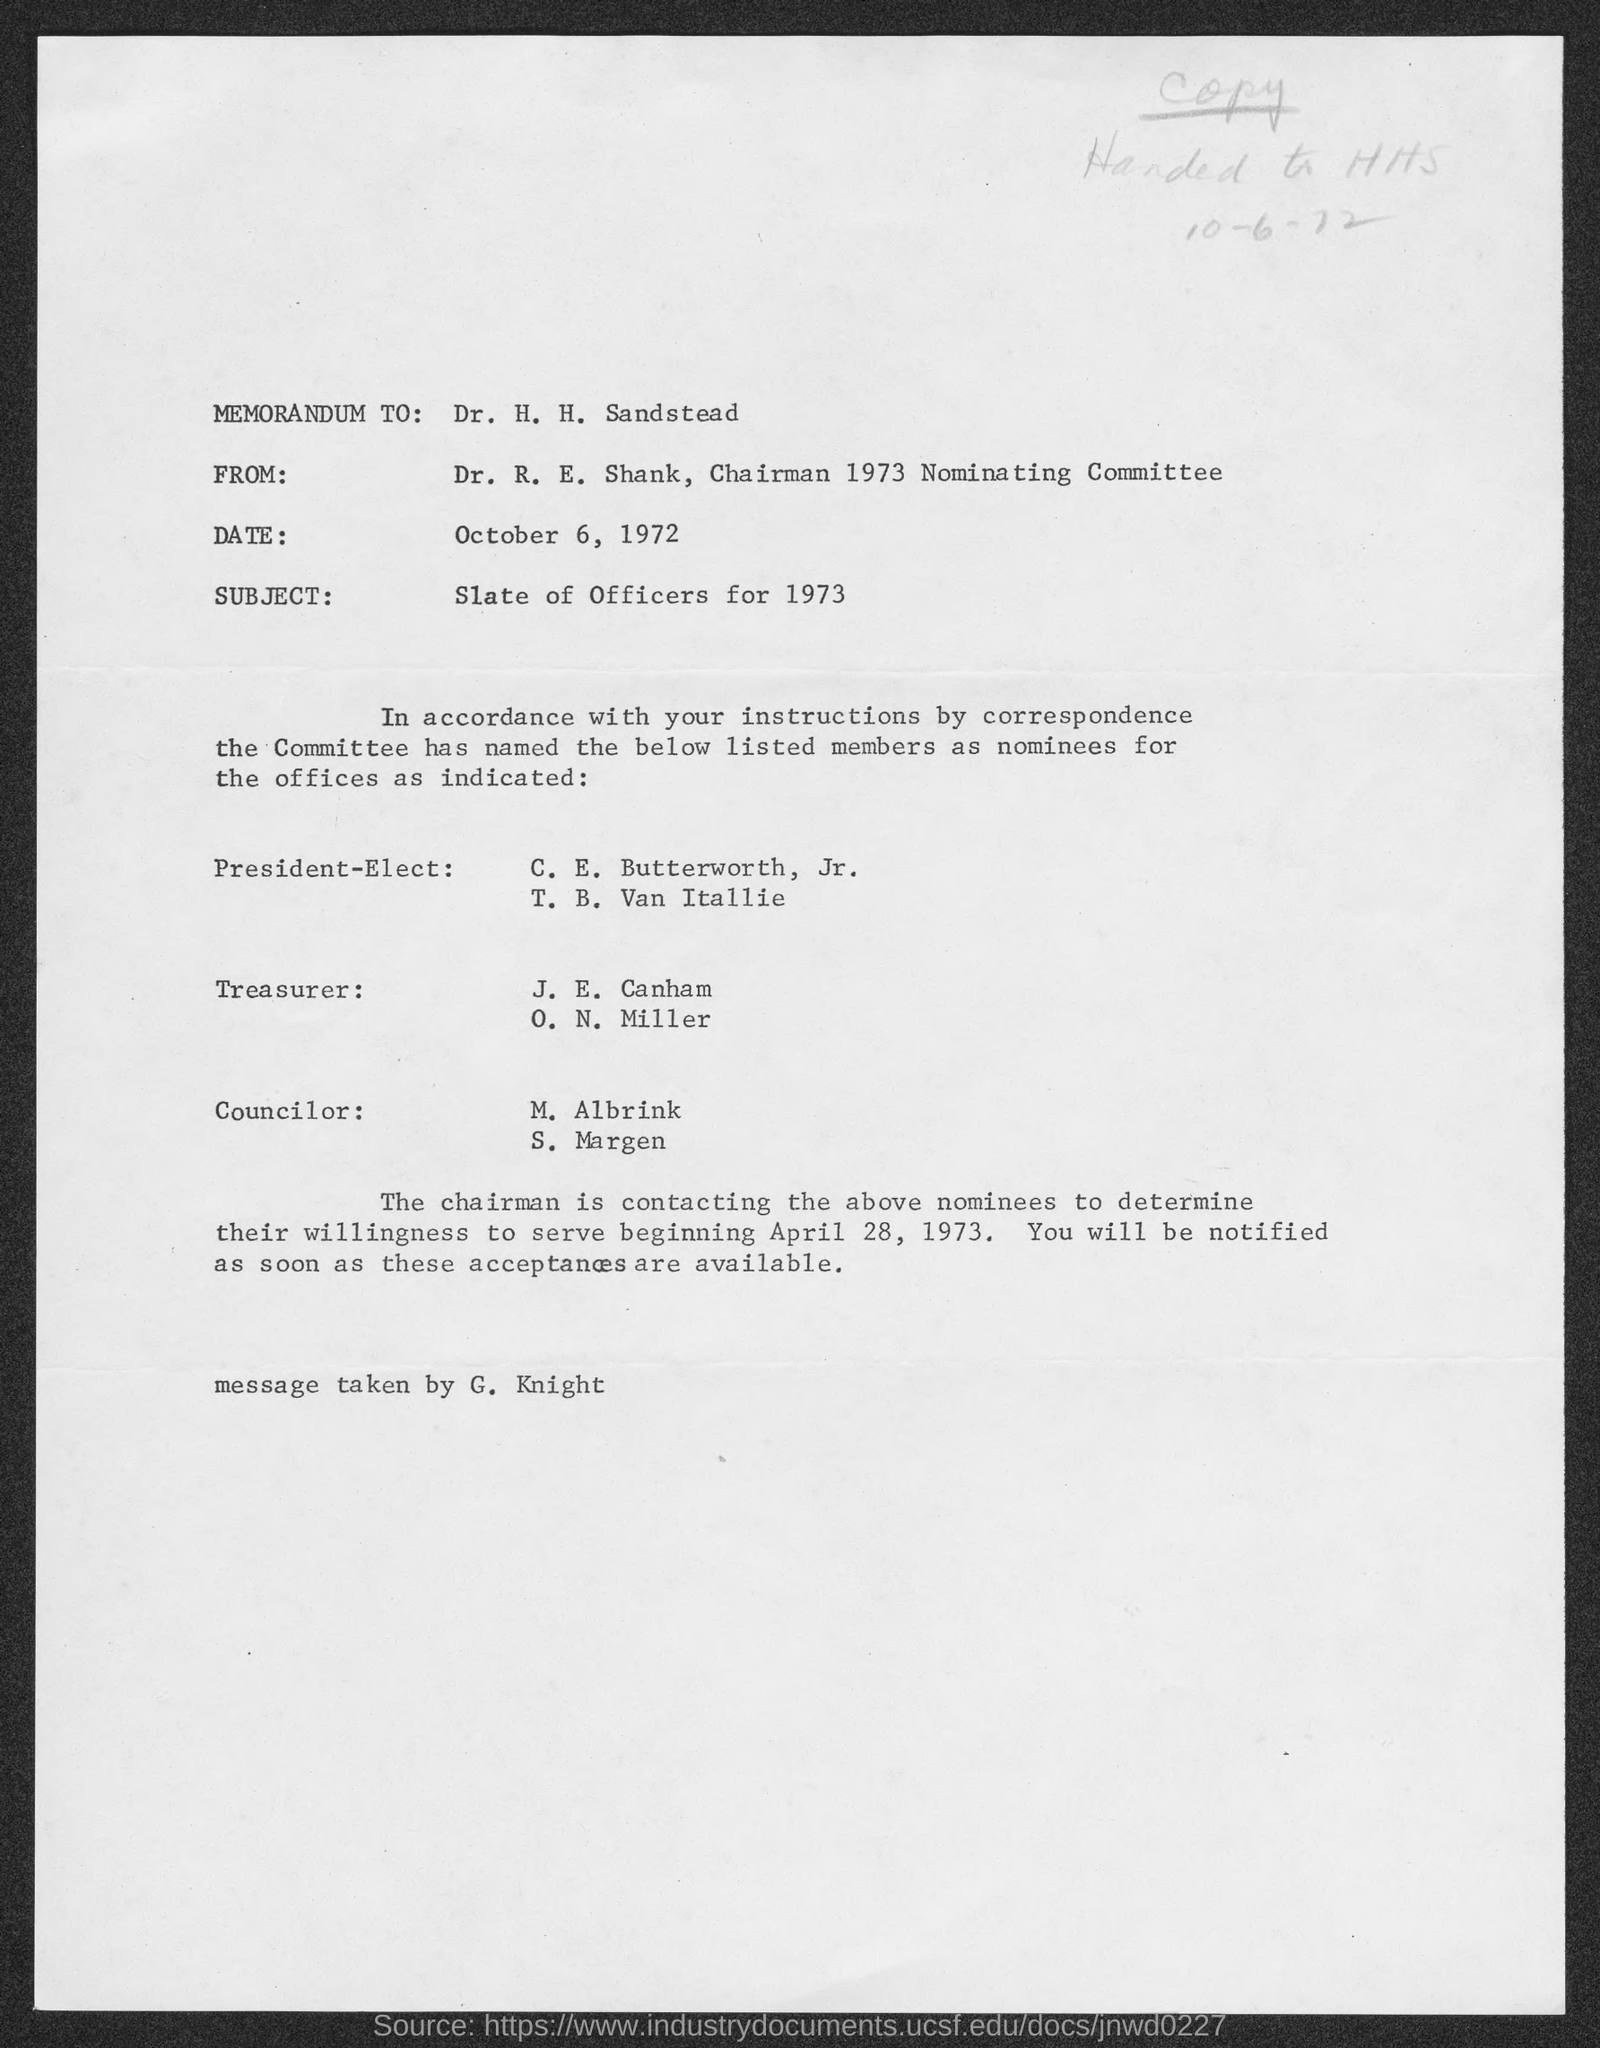Mention a couple of crucial points in this snapshot. The handwritten date on the document is "10-6-72. The date is October 6, 1972. 